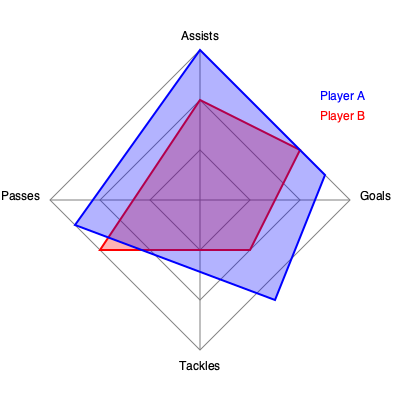As a supporter of the women's soccer league, you're analyzing player performance statistics. The radar chart shows data for two players across four key metrics. Which player demonstrates a more balanced performance across all categories? To determine which player has a more balanced performance, we need to compare the shape and area coverage of each player's polygon on the radar chart:

1. Player A (blue polygon):
   - High in Assists and Goals
   - Moderate in Passes
   - Low in Tackles
   - Shape is elongated and irregular

2. Player B (red polygon):
   - Moderate to high in all categories
   - More consistent across all four metrics
   - Shape is more symmetrical and closer to a square

3. Balanced performance criteria:
   - Even distribution across all categories
   - Consistent skill level in multiple areas
   - Less extreme variations between highest and lowest scores

4. Comparison:
   - Player A excels in two categories but underperforms in others
   - Player B shows more consistent performance across all categories
   - Player B's polygon covers a more balanced area of the chart

5. Conclusion:
   Player B demonstrates a more balanced performance across all categories, as their radar chart polygon is more evenly distributed and shows consistency in all four metrics.
Answer: Player B 